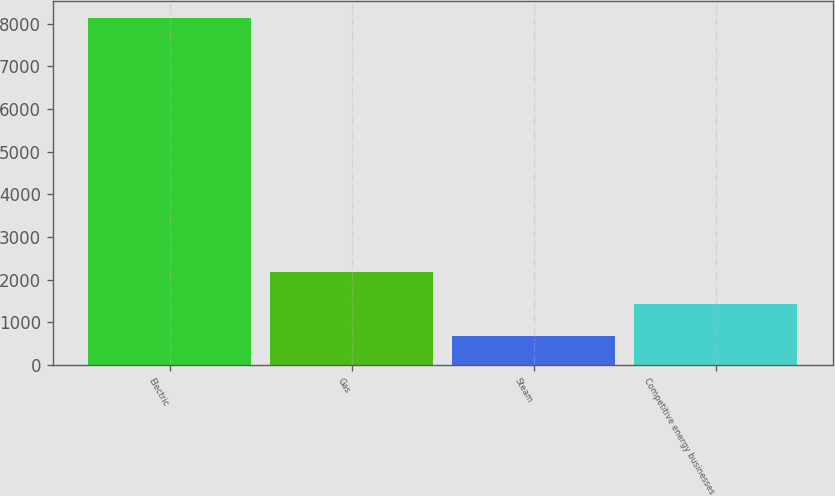<chart> <loc_0><loc_0><loc_500><loc_500><bar_chart><fcel>Electric<fcel>Gas<fcel>Steam<fcel>Competitive energy businesses<nl><fcel>8131<fcel>2172.6<fcel>683<fcel>1427.8<nl></chart> 